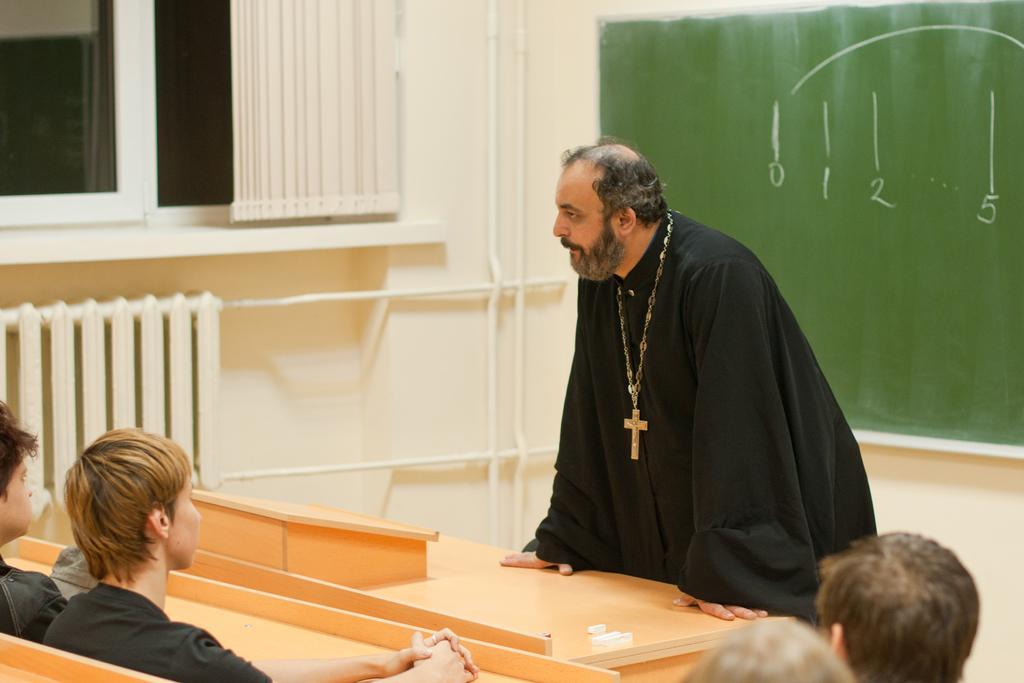Please provide a concise description of this image. In this image in the front there are persons sitting and in the center there is a man standing. In the background there is a board which is green in colour with numbers written on it and there is a wall and there is a window and there is a window curtain. 